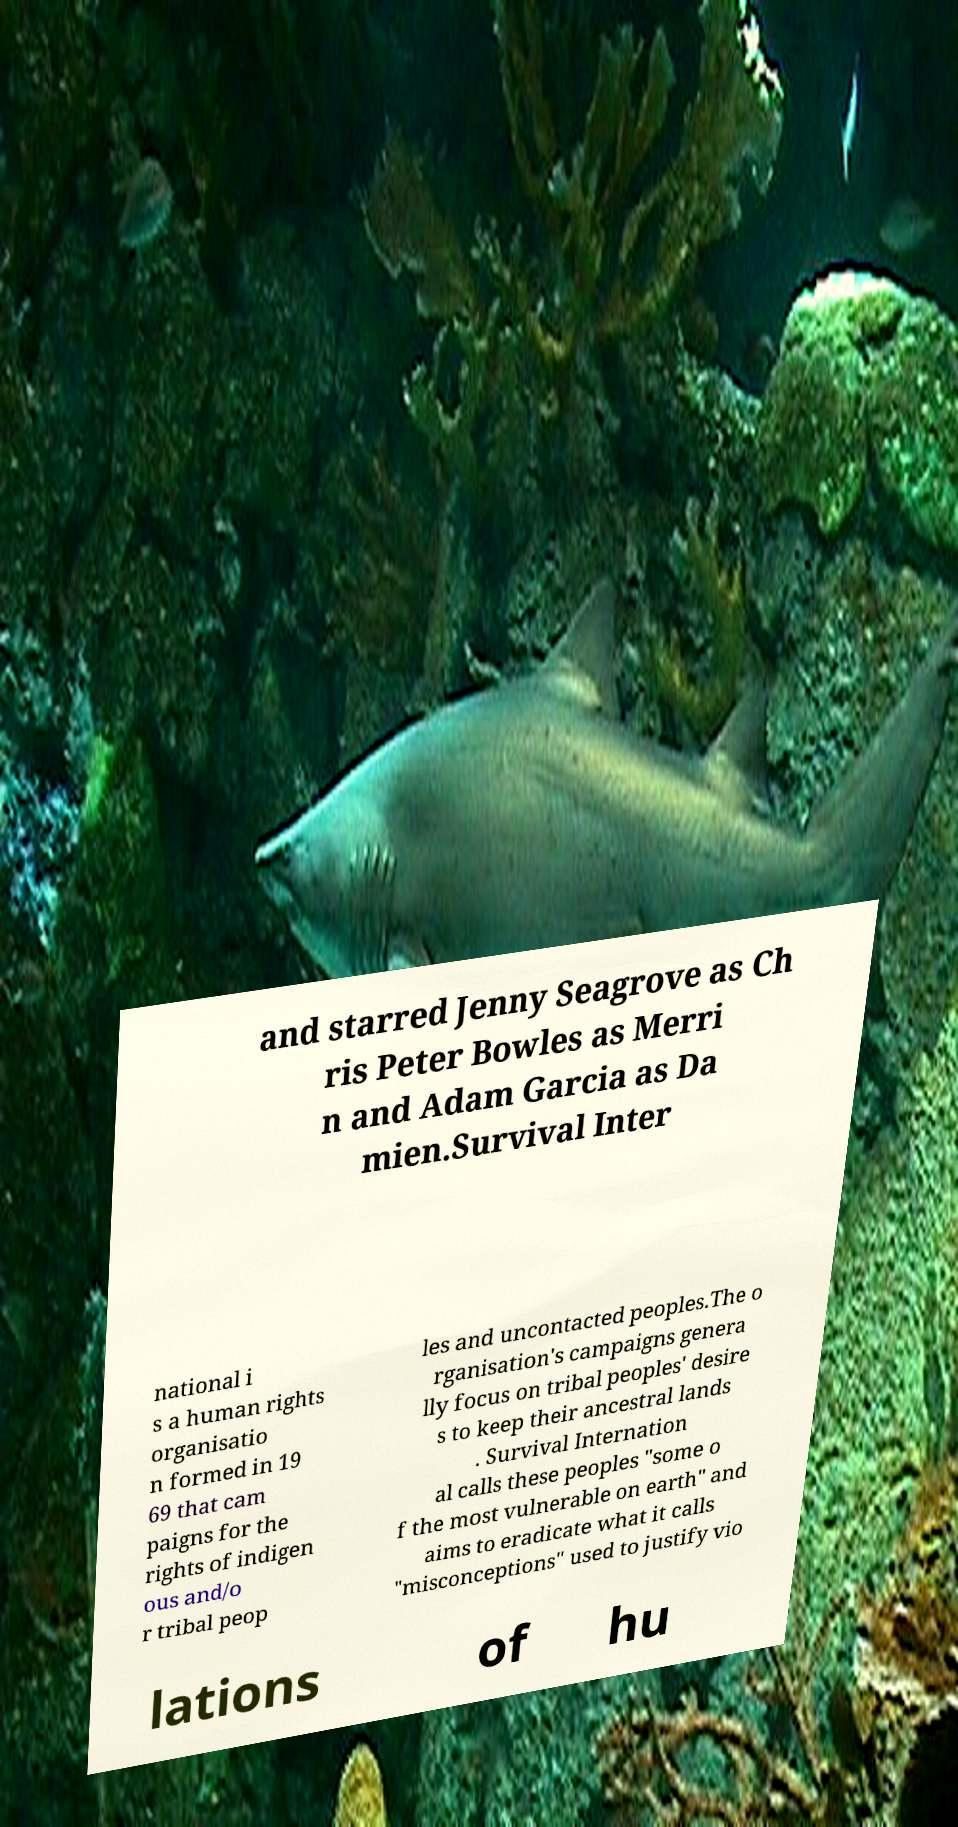Can you read and provide the text displayed in the image?This photo seems to have some interesting text. Can you extract and type it out for me? and starred Jenny Seagrove as Ch ris Peter Bowles as Merri n and Adam Garcia as Da mien.Survival Inter national i s a human rights organisatio n formed in 19 69 that cam paigns for the rights of indigen ous and/o r tribal peop les and uncontacted peoples.The o rganisation's campaigns genera lly focus on tribal peoples' desire s to keep their ancestral lands . Survival Internation al calls these peoples "some o f the most vulnerable on earth" and aims to eradicate what it calls "misconceptions" used to justify vio lations of hu 